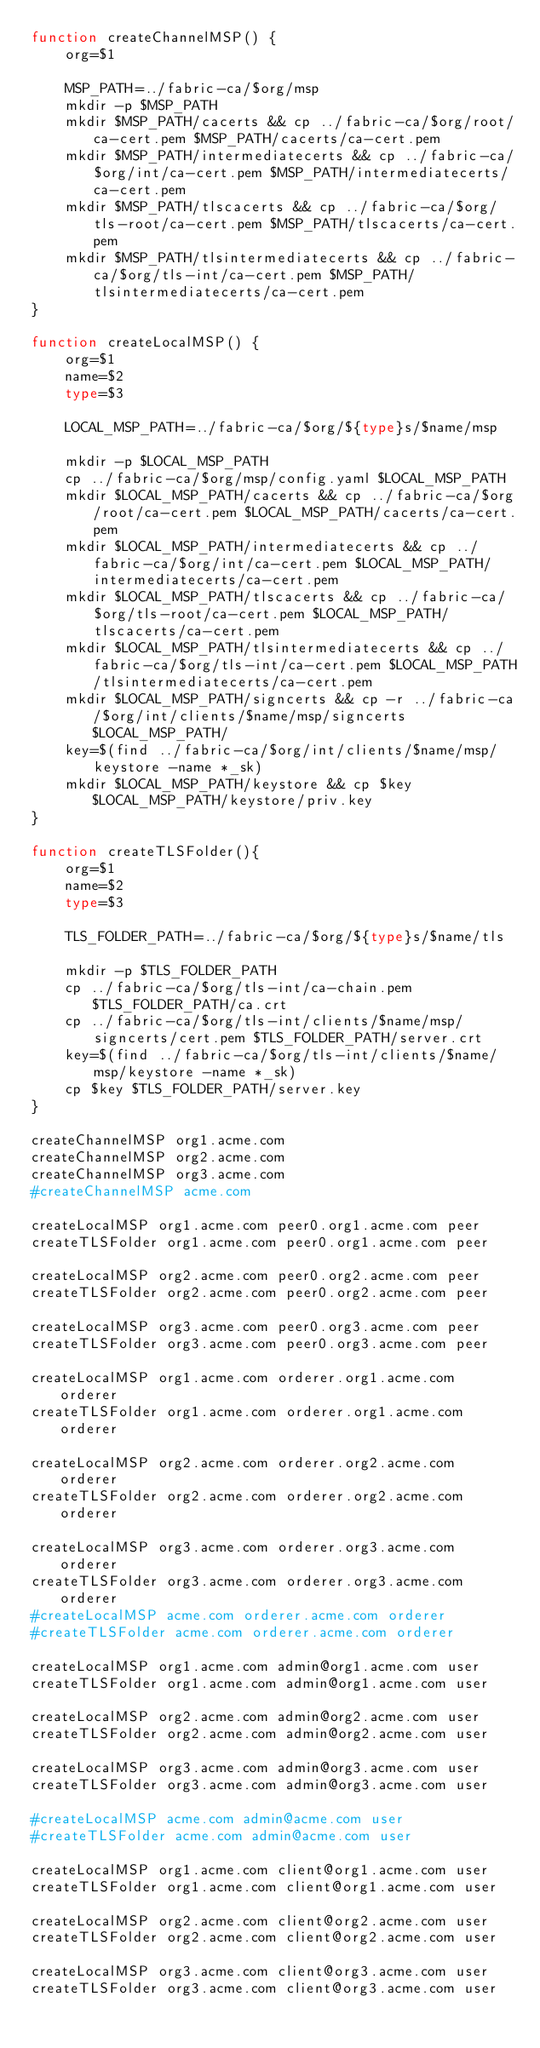<code> <loc_0><loc_0><loc_500><loc_500><_Bash_>function createChannelMSP() {
    org=$1

    MSP_PATH=../fabric-ca/$org/msp
    mkdir -p $MSP_PATH
    mkdir $MSP_PATH/cacerts && cp ../fabric-ca/$org/root/ca-cert.pem $MSP_PATH/cacerts/ca-cert.pem
    mkdir $MSP_PATH/intermediatecerts && cp ../fabric-ca/$org/int/ca-cert.pem $MSP_PATH/intermediatecerts/ca-cert.pem
    mkdir $MSP_PATH/tlscacerts && cp ../fabric-ca/$org/tls-root/ca-cert.pem $MSP_PATH/tlscacerts/ca-cert.pem
    mkdir $MSP_PATH/tlsintermediatecerts && cp ../fabric-ca/$org/tls-int/ca-cert.pem $MSP_PATH/tlsintermediatecerts/ca-cert.pem
}

function createLocalMSP() {
    org=$1
    name=$2
    type=$3

    LOCAL_MSP_PATH=../fabric-ca/$org/${type}s/$name/msp

    mkdir -p $LOCAL_MSP_PATH
    cp ../fabric-ca/$org/msp/config.yaml $LOCAL_MSP_PATH
    mkdir $LOCAL_MSP_PATH/cacerts && cp ../fabric-ca/$org/root/ca-cert.pem $LOCAL_MSP_PATH/cacerts/ca-cert.pem
    mkdir $LOCAL_MSP_PATH/intermediatecerts && cp ../fabric-ca/$org/int/ca-cert.pem $LOCAL_MSP_PATH/intermediatecerts/ca-cert.pem
    mkdir $LOCAL_MSP_PATH/tlscacerts && cp ../fabric-ca/$org/tls-root/ca-cert.pem $LOCAL_MSP_PATH/tlscacerts/ca-cert.pem
    mkdir $LOCAL_MSP_PATH/tlsintermediatecerts && cp ../fabric-ca/$org/tls-int/ca-cert.pem $LOCAL_MSP_PATH/tlsintermediatecerts/ca-cert.pem
    mkdir $LOCAL_MSP_PATH/signcerts && cp -r ../fabric-ca/$org/int/clients/$name/msp/signcerts $LOCAL_MSP_PATH/
    key=$(find ../fabric-ca/$org/int/clients/$name/msp/keystore -name *_sk)
    mkdir $LOCAL_MSP_PATH/keystore && cp $key $LOCAL_MSP_PATH/keystore/priv.key
}

function createTLSFolder(){
    org=$1
    name=$2
    type=$3

    TLS_FOLDER_PATH=../fabric-ca/$org/${type}s/$name/tls

    mkdir -p $TLS_FOLDER_PATH
    cp ../fabric-ca/$org/tls-int/ca-chain.pem $TLS_FOLDER_PATH/ca.crt
    cp ../fabric-ca/$org/tls-int/clients/$name/msp/signcerts/cert.pem $TLS_FOLDER_PATH/server.crt
    key=$(find ../fabric-ca/$org/tls-int/clients/$name/msp/keystore -name *_sk)
    cp $key $TLS_FOLDER_PATH/server.key
}

createChannelMSP org1.acme.com
createChannelMSP org2.acme.com
createChannelMSP org3.acme.com
#createChannelMSP acme.com

createLocalMSP org1.acme.com peer0.org1.acme.com peer
createTLSFolder org1.acme.com peer0.org1.acme.com peer

createLocalMSP org2.acme.com peer0.org2.acme.com peer
createTLSFolder org2.acme.com peer0.org2.acme.com peer

createLocalMSP org3.acme.com peer0.org3.acme.com peer
createTLSFolder org3.acme.com peer0.org3.acme.com peer

createLocalMSP org1.acme.com orderer.org1.acme.com orderer
createTLSFolder org1.acme.com orderer.org1.acme.com orderer

createLocalMSP org2.acme.com orderer.org2.acme.com orderer
createTLSFolder org2.acme.com orderer.org2.acme.com orderer

createLocalMSP org3.acme.com orderer.org3.acme.com orderer
createTLSFolder org3.acme.com orderer.org3.acme.com orderer
#createLocalMSP acme.com orderer.acme.com orderer
#createTLSFolder acme.com orderer.acme.com orderer

createLocalMSP org1.acme.com admin@org1.acme.com user
createTLSFolder org1.acme.com admin@org1.acme.com user

createLocalMSP org2.acme.com admin@org2.acme.com user
createTLSFolder org2.acme.com admin@org2.acme.com user

createLocalMSP org3.acme.com admin@org3.acme.com user
createTLSFolder org3.acme.com admin@org3.acme.com user

#createLocalMSP acme.com admin@acme.com user
#createTLSFolder acme.com admin@acme.com user

createLocalMSP org1.acme.com client@org1.acme.com user
createTLSFolder org1.acme.com client@org1.acme.com user

createLocalMSP org2.acme.com client@org2.acme.com user
createTLSFolder org2.acme.com client@org2.acme.com user

createLocalMSP org3.acme.com client@org3.acme.com user
createTLSFolder org3.acme.com client@org3.acme.com user
</code> 